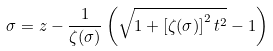<formula> <loc_0><loc_0><loc_500><loc_500>\sigma = z - \frac { 1 } { \zeta ( \sigma ) } \left ( \sqrt { 1 + \left [ \zeta ( \sigma ) \right ] ^ { 2 } t ^ { 2 } } - 1 \right )</formula> 